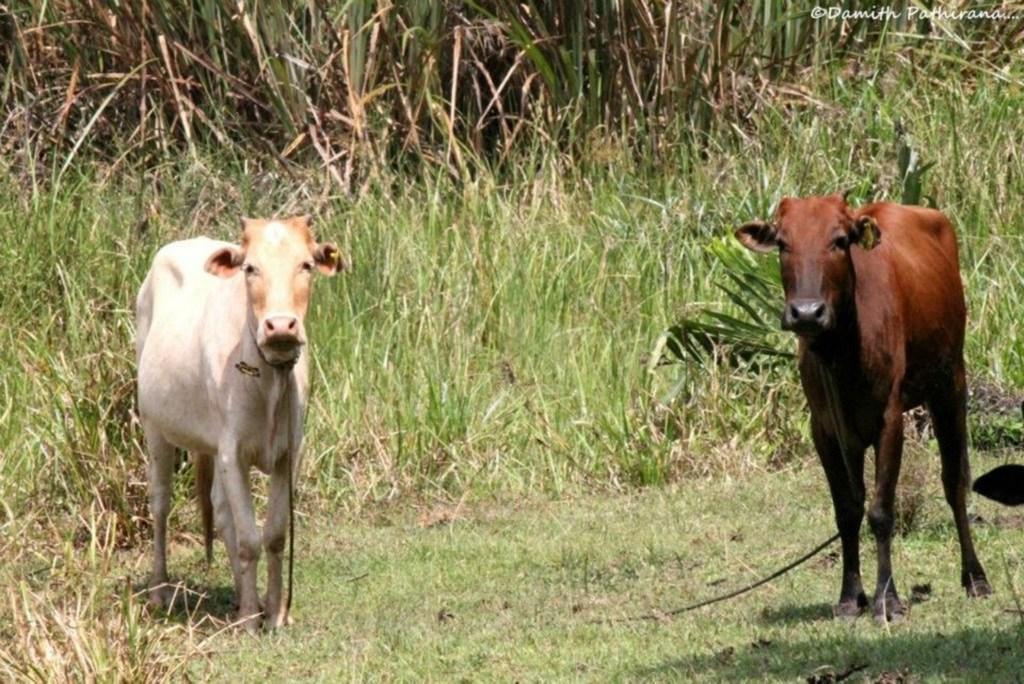Can you describe this image briefly? In this image I can see two animals. Among them one is in white color and another is in brown. In the back there is a green color grass. 